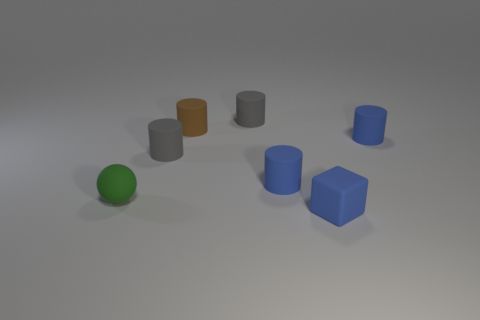There is a thing in front of the small sphere in front of the tiny brown rubber cylinder; what is its color?
Offer a very short reply. Blue. How many blue objects are small blocks or tiny rubber cylinders?
Keep it short and to the point. 3. There is a rubber thing that is to the left of the tiny brown rubber thing and behind the green ball; what is its color?
Keep it short and to the point. Gray. How many small objects are rubber balls or blue rubber cylinders?
Offer a terse response. 3. There is a small green object; what shape is it?
Offer a very short reply. Sphere. How many shiny objects are spheres or big cyan balls?
Your answer should be compact. 0. There is a green sphere behind the block; what size is it?
Make the answer very short. Small. What size is the brown cylinder that is made of the same material as the tiny cube?
Keep it short and to the point. Small. What number of tiny cylinders are the same color as the tiny block?
Provide a succinct answer. 2. Are any tiny red cubes visible?
Provide a short and direct response. No. 